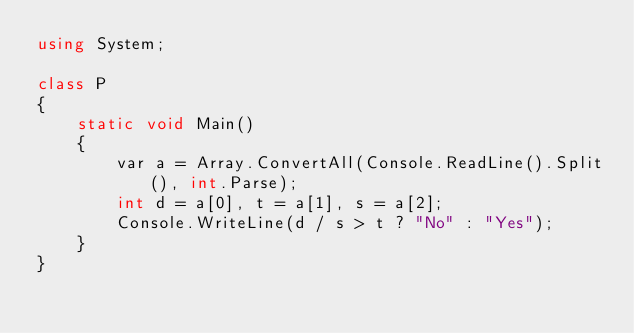<code> <loc_0><loc_0><loc_500><loc_500><_C#_>using System;

class P
{
    static void Main()
    {
        var a = Array.ConvertAll(Console.ReadLine().Split(), int.Parse);
        int d = a[0], t = a[1], s = a[2];
        Console.WriteLine(d / s > t ? "No" : "Yes");
    }
}</code> 